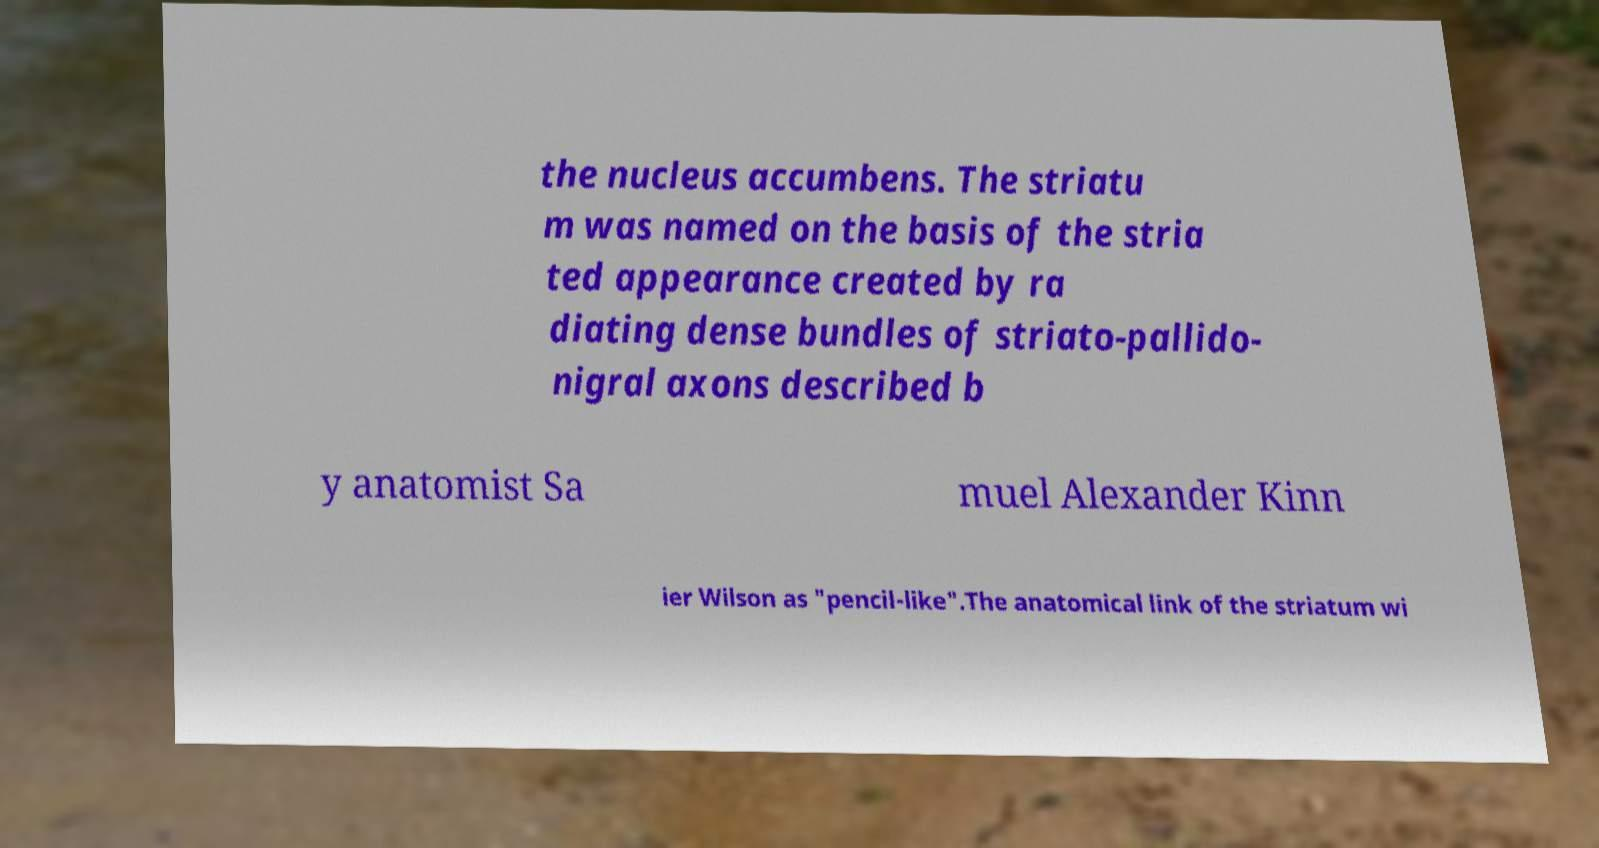Please read and relay the text visible in this image. What does it say? the nucleus accumbens. The striatu m was named on the basis of the stria ted appearance created by ra diating dense bundles of striato-pallido- nigral axons described b y anatomist Sa muel Alexander Kinn ier Wilson as "pencil-like".The anatomical link of the striatum wi 